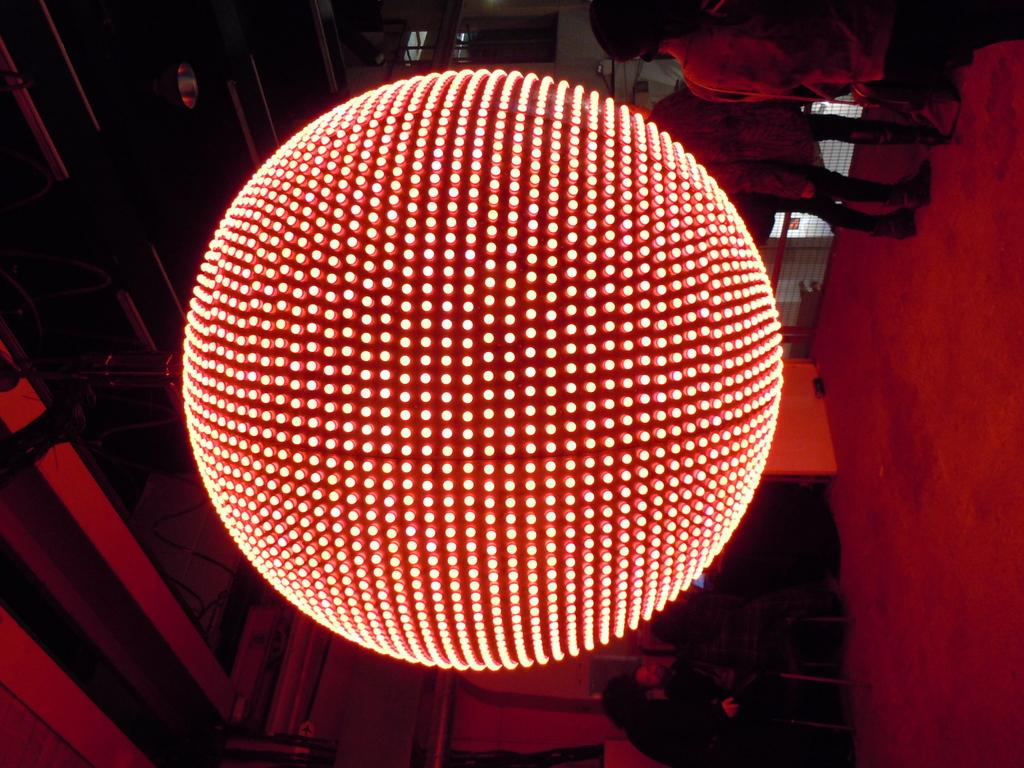What is the main subject in the center of the image? There is a light ball in the center of the image. Where is the bun located in the image? There is no bun present in the image. Is the light ball being used for swimming in the image? The image does not depict any swimming activity, and the light ball is not being used for swimming. 